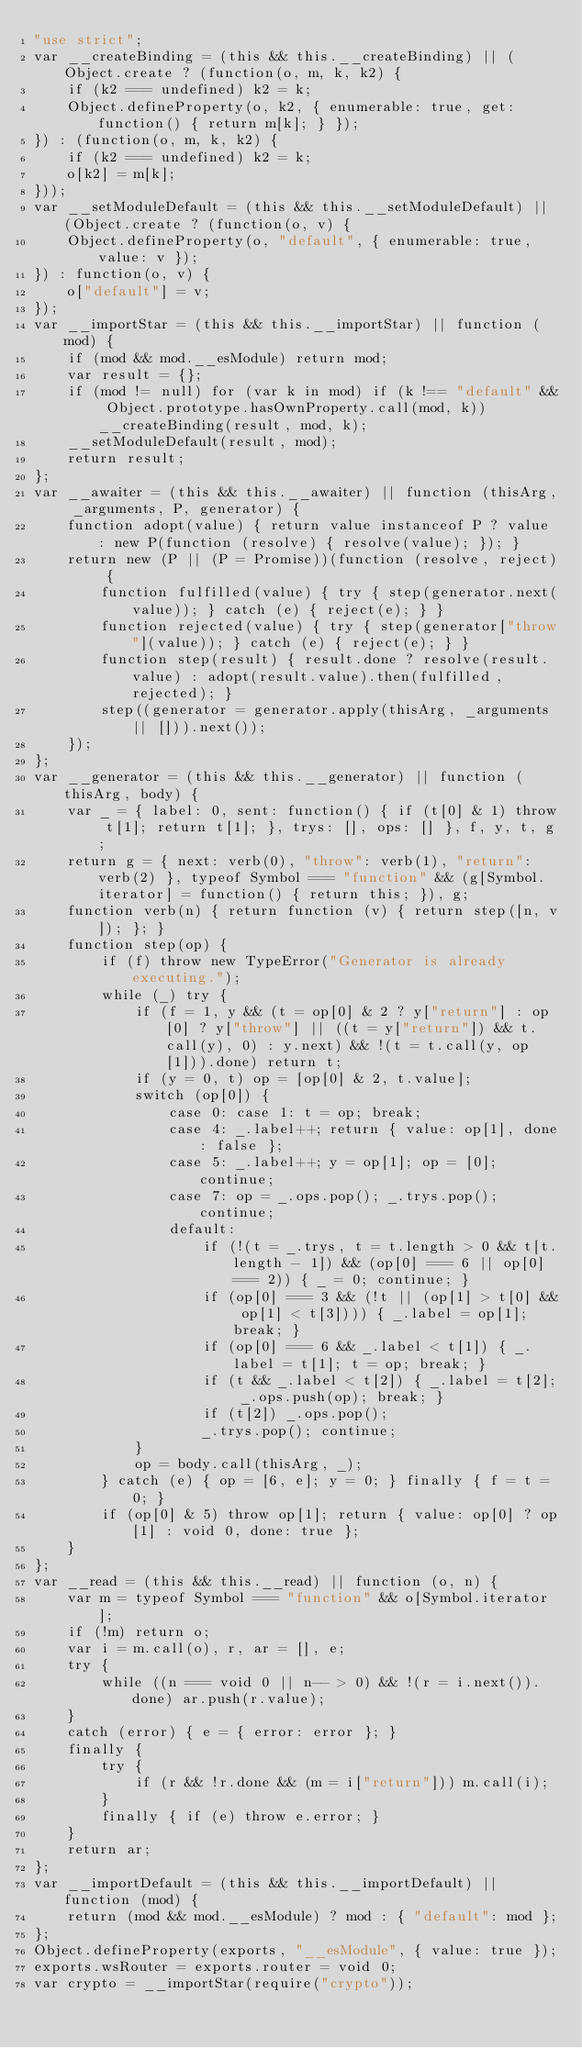<code> <loc_0><loc_0><loc_500><loc_500><_JavaScript_>"use strict";
var __createBinding = (this && this.__createBinding) || (Object.create ? (function(o, m, k, k2) {
    if (k2 === undefined) k2 = k;
    Object.defineProperty(o, k2, { enumerable: true, get: function() { return m[k]; } });
}) : (function(o, m, k, k2) {
    if (k2 === undefined) k2 = k;
    o[k2] = m[k];
}));
var __setModuleDefault = (this && this.__setModuleDefault) || (Object.create ? (function(o, v) {
    Object.defineProperty(o, "default", { enumerable: true, value: v });
}) : function(o, v) {
    o["default"] = v;
});
var __importStar = (this && this.__importStar) || function (mod) {
    if (mod && mod.__esModule) return mod;
    var result = {};
    if (mod != null) for (var k in mod) if (k !== "default" && Object.prototype.hasOwnProperty.call(mod, k)) __createBinding(result, mod, k);
    __setModuleDefault(result, mod);
    return result;
};
var __awaiter = (this && this.__awaiter) || function (thisArg, _arguments, P, generator) {
    function adopt(value) { return value instanceof P ? value : new P(function (resolve) { resolve(value); }); }
    return new (P || (P = Promise))(function (resolve, reject) {
        function fulfilled(value) { try { step(generator.next(value)); } catch (e) { reject(e); } }
        function rejected(value) { try { step(generator["throw"](value)); } catch (e) { reject(e); } }
        function step(result) { result.done ? resolve(result.value) : adopt(result.value).then(fulfilled, rejected); }
        step((generator = generator.apply(thisArg, _arguments || [])).next());
    });
};
var __generator = (this && this.__generator) || function (thisArg, body) {
    var _ = { label: 0, sent: function() { if (t[0] & 1) throw t[1]; return t[1]; }, trys: [], ops: [] }, f, y, t, g;
    return g = { next: verb(0), "throw": verb(1), "return": verb(2) }, typeof Symbol === "function" && (g[Symbol.iterator] = function() { return this; }), g;
    function verb(n) { return function (v) { return step([n, v]); }; }
    function step(op) {
        if (f) throw new TypeError("Generator is already executing.");
        while (_) try {
            if (f = 1, y && (t = op[0] & 2 ? y["return"] : op[0] ? y["throw"] || ((t = y["return"]) && t.call(y), 0) : y.next) && !(t = t.call(y, op[1])).done) return t;
            if (y = 0, t) op = [op[0] & 2, t.value];
            switch (op[0]) {
                case 0: case 1: t = op; break;
                case 4: _.label++; return { value: op[1], done: false };
                case 5: _.label++; y = op[1]; op = [0]; continue;
                case 7: op = _.ops.pop(); _.trys.pop(); continue;
                default:
                    if (!(t = _.trys, t = t.length > 0 && t[t.length - 1]) && (op[0] === 6 || op[0] === 2)) { _ = 0; continue; }
                    if (op[0] === 3 && (!t || (op[1] > t[0] && op[1] < t[3]))) { _.label = op[1]; break; }
                    if (op[0] === 6 && _.label < t[1]) { _.label = t[1]; t = op; break; }
                    if (t && _.label < t[2]) { _.label = t[2]; _.ops.push(op); break; }
                    if (t[2]) _.ops.pop();
                    _.trys.pop(); continue;
            }
            op = body.call(thisArg, _);
        } catch (e) { op = [6, e]; y = 0; } finally { f = t = 0; }
        if (op[0] & 5) throw op[1]; return { value: op[0] ? op[1] : void 0, done: true };
    }
};
var __read = (this && this.__read) || function (o, n) {
    var m = typeof Symbol === "function" && o[Symbol.iterator];
    if (!m) return o;
    var i = m.call(o), r, ar = [], e;
    try {
        while ((n === void 0 || n-- > 0) && !(r = i.next()).done) ar.push(r.value);
    }
    catch (error) { e = { error: error }; }
    finally {
        try {
            if (r && !r.done && (m = i["return"])) m.call(i);
        }
        finally { if (e) throw e.error; }
    }
    return ar;
};
var __importDefault = (this && this.__importDefault) || function (mod) {
    return (mod && mod.__esModule) ? mod : { "default": mod };
};
Object.defineProperty(exports, "__esModule", { value: true });
exports.wsRouter = exports.router = void 0;
var crypto = __importStar(require("crypto"));</code> 